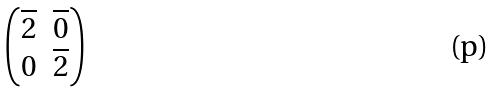<formula> <loc_0><loc_0><loc_500><loc_500>\begin{pmatrix} \overline { 2 } & \overline { 0 } \\ 0 & \overline { 2 } \end{pmatrix}</formula> 